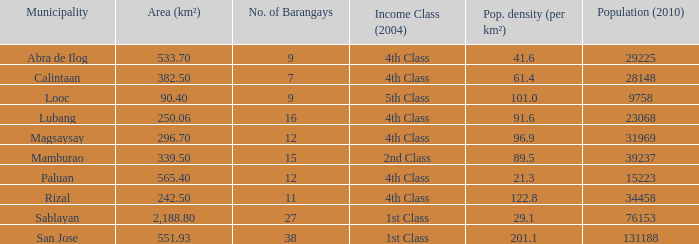What is the population density for the city of lubang? 1.0. Could you parse the entire table as a dict? {'header': ['Municipality', 'Area (km²)', 'No. of Barangays', 'Income Class (2004)', 'Pop. density (per km²)', 'Population (2010)'], 'rows': [['Abra de Ilog', '533.70', '9', '4th Class', '41.6', '29225'], ['Calintaan', '382.50', '7', '4th Class', '61.4', '28148'], ['Looc', '90.40', '9', '5th Class', '101.0', '9758'], ['Lubang', '250.06', '16', '4th Class', '91.6', '23068'], ['Magsaysay', '296.70', '12', '4th Class', '96.9', '31969'], ['Mamburao', '339.50', '15', '2nd Class', '89.5', '39237'], ['Paluan', '565.40', '12', '4th Class', '21.3', '15223'], ['Rizal', '242.50', '11', '4th Class', '122.8', '34458'], ['Sablayan', '2,188.80', '27', '1st Class', '29.1', '76153'], ['San Jose', '551.93', '38', '1st Class', '201.1', '131188']]} 